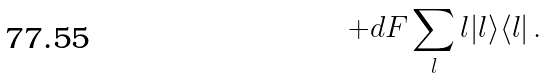<formula> <loc_0><loc_0><loc_500><loc_500>+ d F \sum _ { l } l | l \rangle \langle l | \, .</formula> 